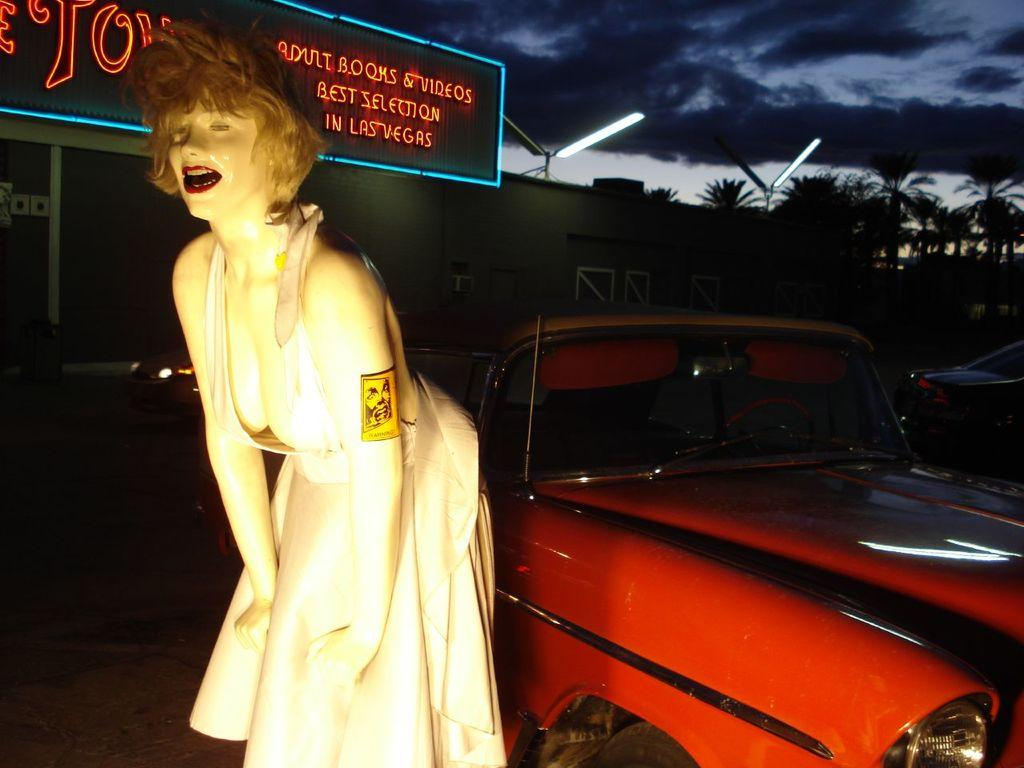What is the main subject in the image? There is a dummy in the image. What else can be seen in the image besides the dummy? There are vehicles, a building, a hoarding, lights, trees, and the sky visible in the image. Can you describe the background of the image? The background of the image includes a building, a hoarding, trees, and the sky with clouds. What type of lighting is present in the image? There are lights in the image. What type of coat is hanging in the drawer in the image? There is no coat or drawer present in the image. 